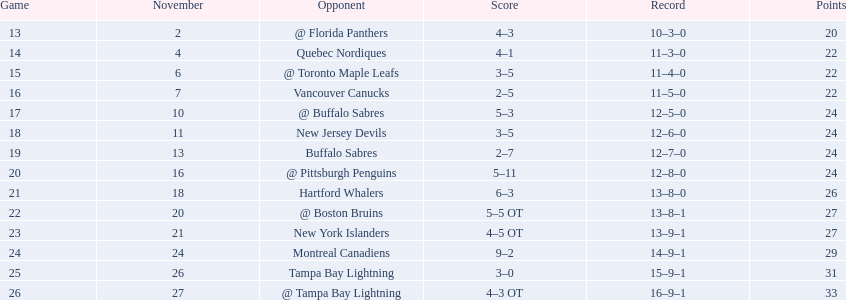What were the tallies of the 1993-94 philadelphia flyers season? 4–3, 4–1, 3–5, 2–5, 5–3, 3–5, 2–7, 5–11, 6–3, 5–5 OT, 4–5 OT, 9–2, 3–0, 4–3 OT. Which of these teams experienced a 4-5 ot result? New York Islanders. 